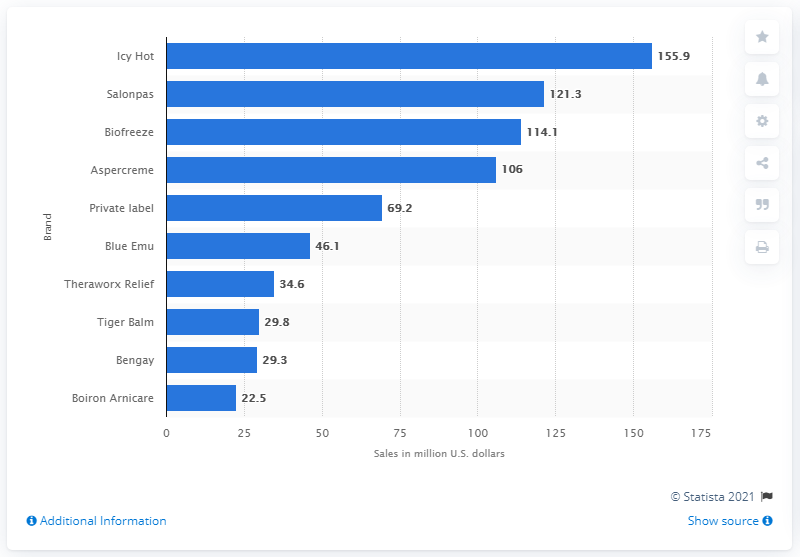Specify some key components in this picture. In 2019, Salonpas was the second-best-selling brand in terms of sales. In 2019, Icy Hot was the top selling external analgesic rub brand in the country. Icy Hot generated $155.9 million in sales in 2019. 